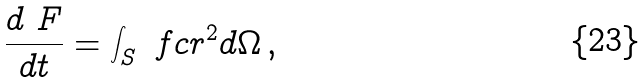Convert formula to latex. <formula><loc_0><loc_0><loc_500><loc_500>\frac { d \ F } { d t } = \int _ { S } \ f c r ^ { 2 } d \Omega \, ,</formula> 